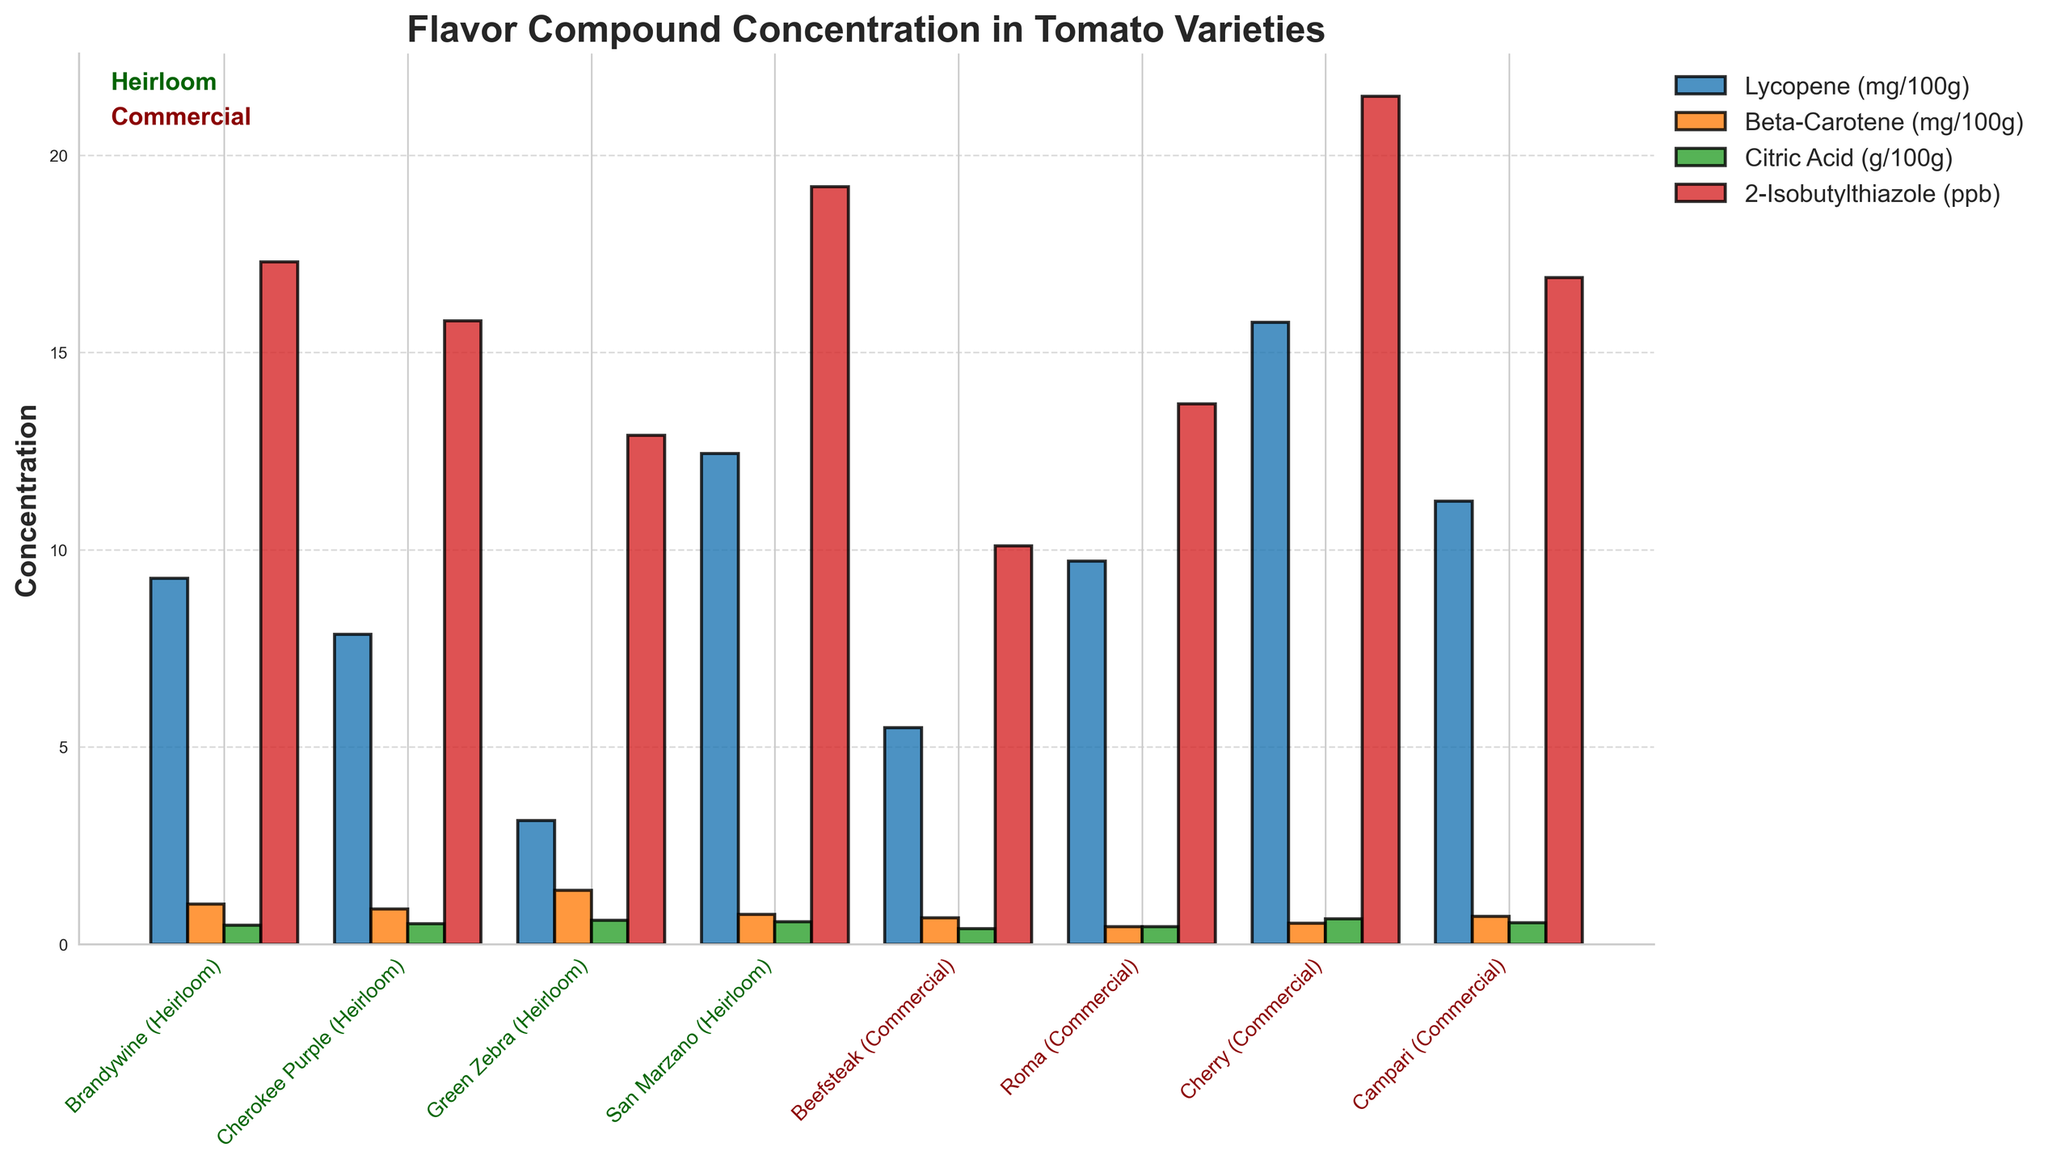What's the highest concentration of Lycopene among the tomato varieties? First, look at the bars corresponding to Lycopene (mg/100g). The tallest bar indicates the highest concentration. The Cherry (Commercial) variety has the tallest bar for Lycopene at 15.77 mg/100g.
Answer: Cherry (Commercial) Which tomato variety has the lowest concentration of Beta-Carotene? Find the shortest bar corresponding to Beta-Carotene (mg/100g). The Roma (Commercial) variety has the shortest bar for Beta-Carotene concentration at 0.45 mg/100g.
Answer: Roma (Commercial) How does the concentration of Citric Acid in San Marzano (Heirloom) compare to Beefsteak (Commercial)? Locate the bars for Citric Acid (g/100g) for both San Marzano (Heirloom) and Beefsteak (Commercial). The bar for San Marzano is taller (0.57 g/100g) compared to Beefsteak (0.39 g/100g).
Answer: San Marzano is higher Which heirloom variety has the highest concentration of 2-Isobutylthiazole? Among the heirloom varieties, find the highest bar for 2-Isobutylthiazole (ppb). The San Marzano (Heirloom) variety has the highest concentration at 19.2 ppb.
Answer: San Marzano (Heirloom) Calculate the average concentration of Lycopene in all commercial varieties. Identify the bars for Lycopene (mg/100g) for commercial varieties: Beefsteak (5.49), Roma (9.71), Cherry (15.77), and Campari (11.23). Calculate the average: (5.49 + 9.71 + 15.77 + 11.23) / 4 = 10.05 mg/100g.
Answer: 10.05 Compare the total concentration of Beta-Carotene across all heirloom varieties to all commercial varieties. Sum Beta-Carotene (mg/100g) for heirloom varieties: Brandywine (1.02), Cherokee Purple (0.89), Green Zebra (1.37), San Marzano (0.76) for a total of 4.04 mg/100g. Sum for commercial varieties: Beefsteak (0.67), Roma (0.45), Cherry (0.53), Campari (0.71) for a total of 2.36 mg/100g. Compare: 4.04 is greater than 2.36.
Answer: Heirloom is higher How does the concentration of 2-Isobutylthiazole in the Green Zebra (Heirloom) compare visually to the Roma (Commercial)? Observe the bars for 2-Isobutylthiazole (ppb) for both varieties. Green Zebra (Heirloom) has a lower bar (12.9 ppb) compared to Roma (Commercial) (13.7 ppb).
Answer: Roma is higher Which tomato variety has the closest concentration of Citric Acid to the average concentration across all varieties? Calculate the average concentration of Citric Acid (g/100g): (0.48 + 0.52 + 0.61 + 0.57 + 0.39 + 0.44 + 0.64 + 0.55) / 8 = 0.525. Compare each variety to this average value. Cherokee Purple (Heirloom) at 0.52 g/100g is the closest to 0.525.
Answer: Cherokee Purple (Heirloom) What's the difference in Lycopene concentration between the Cherry (Commercial) and the Brandywine (Heirloom) varieties? Look at the Lycopene bars and find the values for Cherry (15.77 mg/100g) and Brandywine (9.27 mg/100g). Compute the difference: 15.77 - 9.27 = 6.50 mg/100g.
Answer: 6.50 